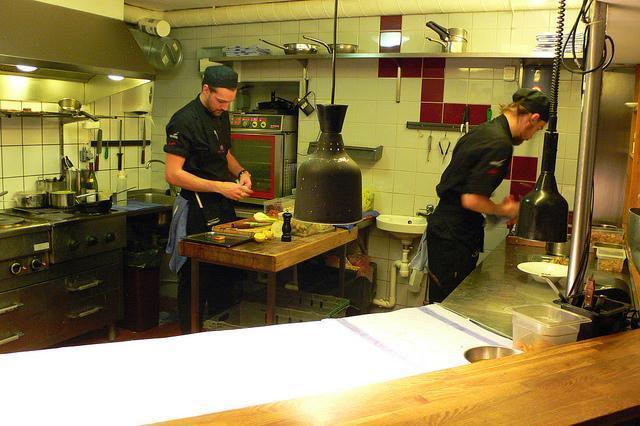How many dining tables can be seen?
Give a very brief answer. 1. How many ovens are visible?
Give a very brief answer. 2. How many people are there?
Give a very brief answer. 2. How many red umbrellas are there?
Give a very brief answer. 0. 